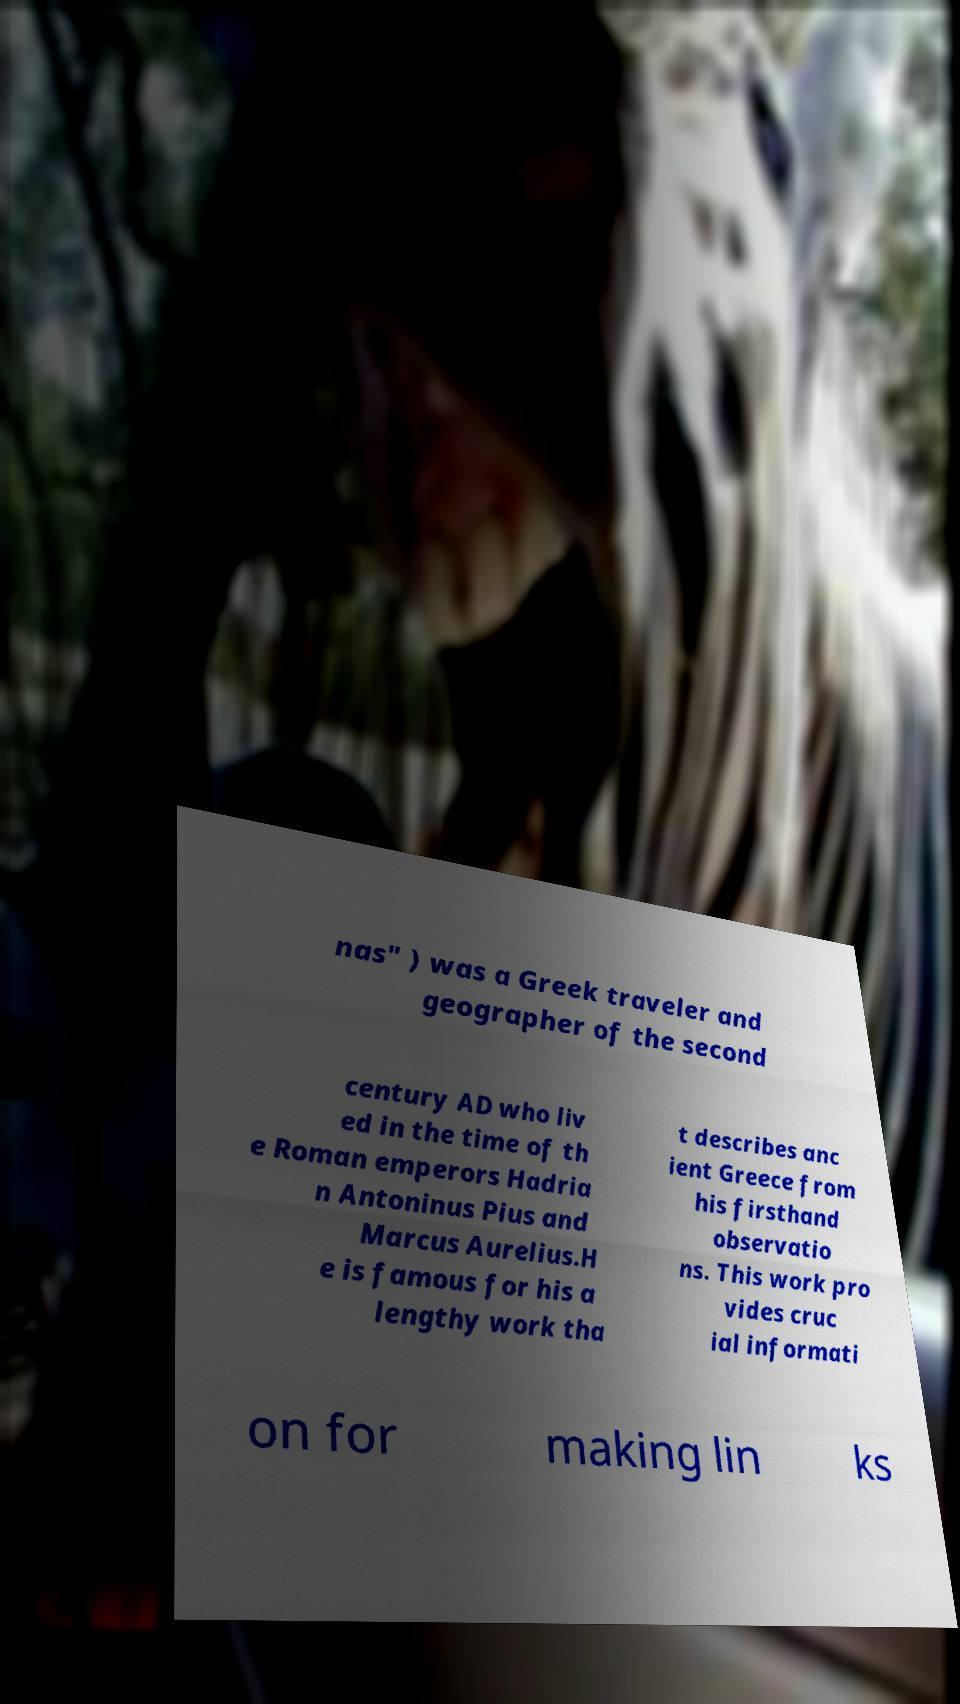For documentation purposes, I need the text within this image transcribed. Could you provide that? nas" ) was a Greek traveler and geographer of the second century AD who liv ed in the time of th e Roman emperors Hadria n Antoninus Pius and Marcus Aurelius.H e is famous for his a lengthy work tha t describes anc ient Greece from his firsthand observatio ns. This work pro vides cruc ial informati on for making lin ks 